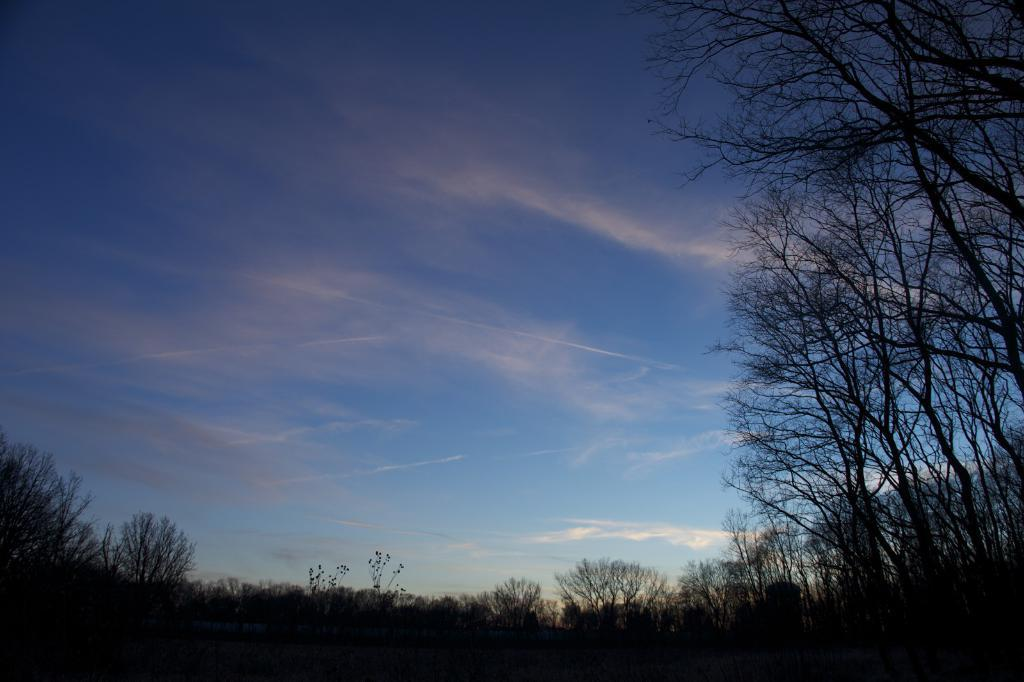What type of vegetation can be seen in the image? There are trees in the image. What part of the natural environment is visible in the image? The sky is visible in the image. What can be observed in the sky in the image? Clouds are present in the image. What type of stone is being exchanged between the clouds in the image? There is no stone or exchange taking place between the clouds in the image; the clouds are simply present in the sky. 